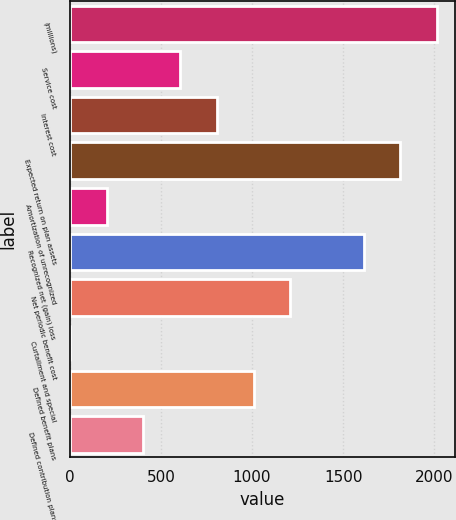Convert chart. <chart><loc_0><loc_0><loc_500><loc_500><bar_chart><fcel>(millions)<fcel>Service cost<fcel>Interest cost<fcel>Expected return on plan assets<fcel>Amortization of unrecognized<fcel>Recognized net (gain) loss<fcel>Net periodic benefit cost<fcel>Curtailment and special<fcel>Defined benefit plans<fcel>Defined contribution plans<nl><fcel>2015<fcel>605.2<fcel>806.6<fcel>1813.6<fcel>202.4<fcel>1612.2<fcel>1209.4<fcel>1<fcel>1008<fcel>403.8<nl></chart> 